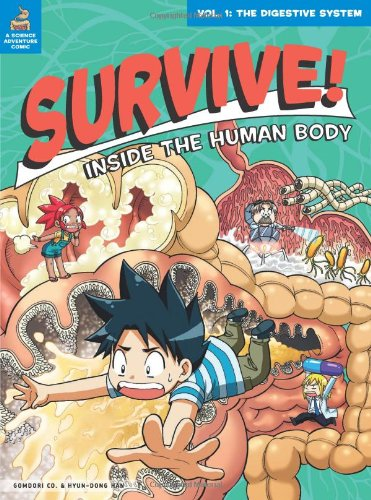Is there a specific educational concept that this book aims to teach? The primary educational concept of this book is the human digestive system. It aims to teach young readers about the processes of digestion through an engaging, story-driven format. 